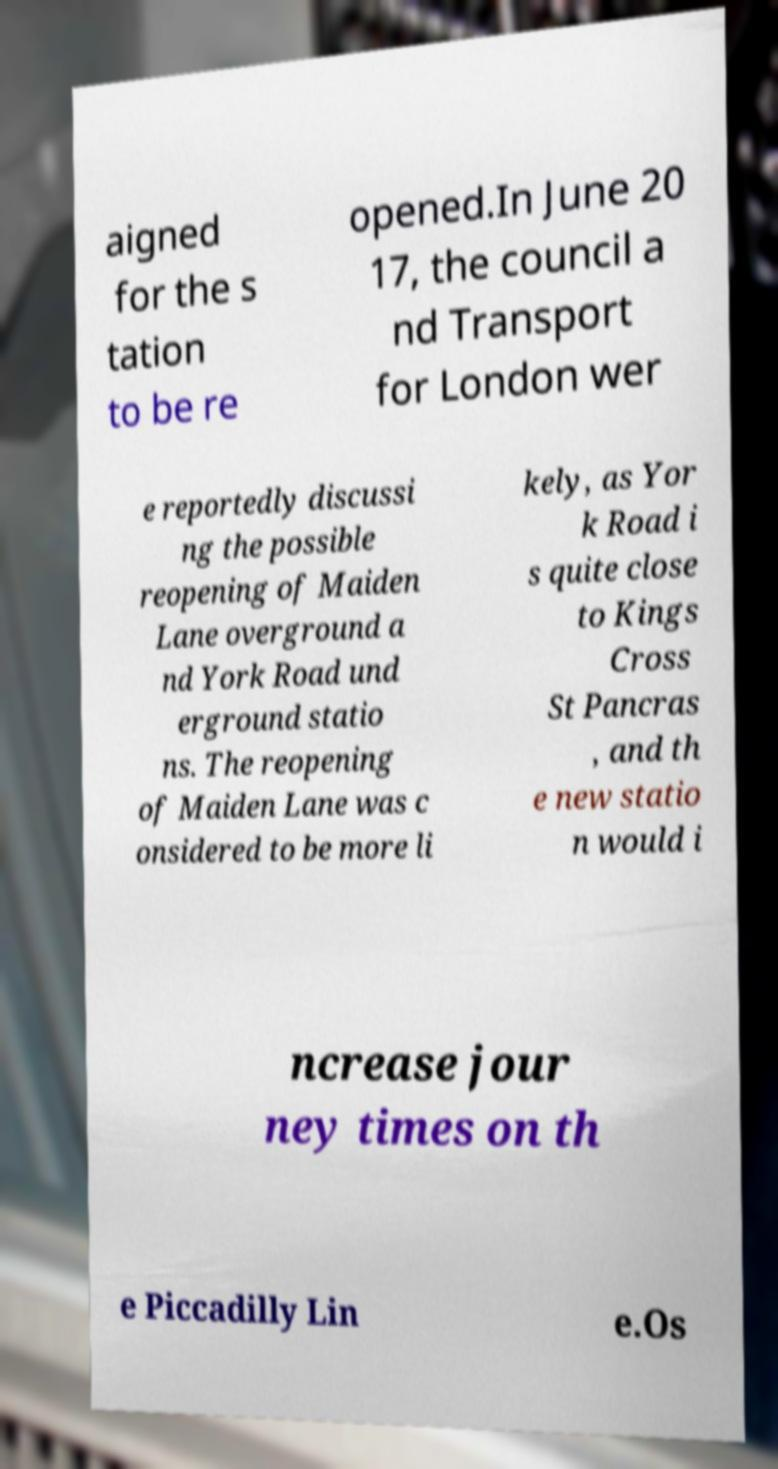Could you assist in decoding the text presented in this image and type it out clearly? aigned for the s tation to be re opened.In June 20 17, the council a nd Transport for London wer e reportedly discussi ng the possible reopening of Maiden Lane overground a nd York Road und erground statio ns. The reopening of Maiden Lane was c onsidered to be more li kely, as Yor k Road i s quite close to Kings Cross St Pancras , and th e new statio n would i ncrease jour ney times on th e Piccadilly Lin e.Os 